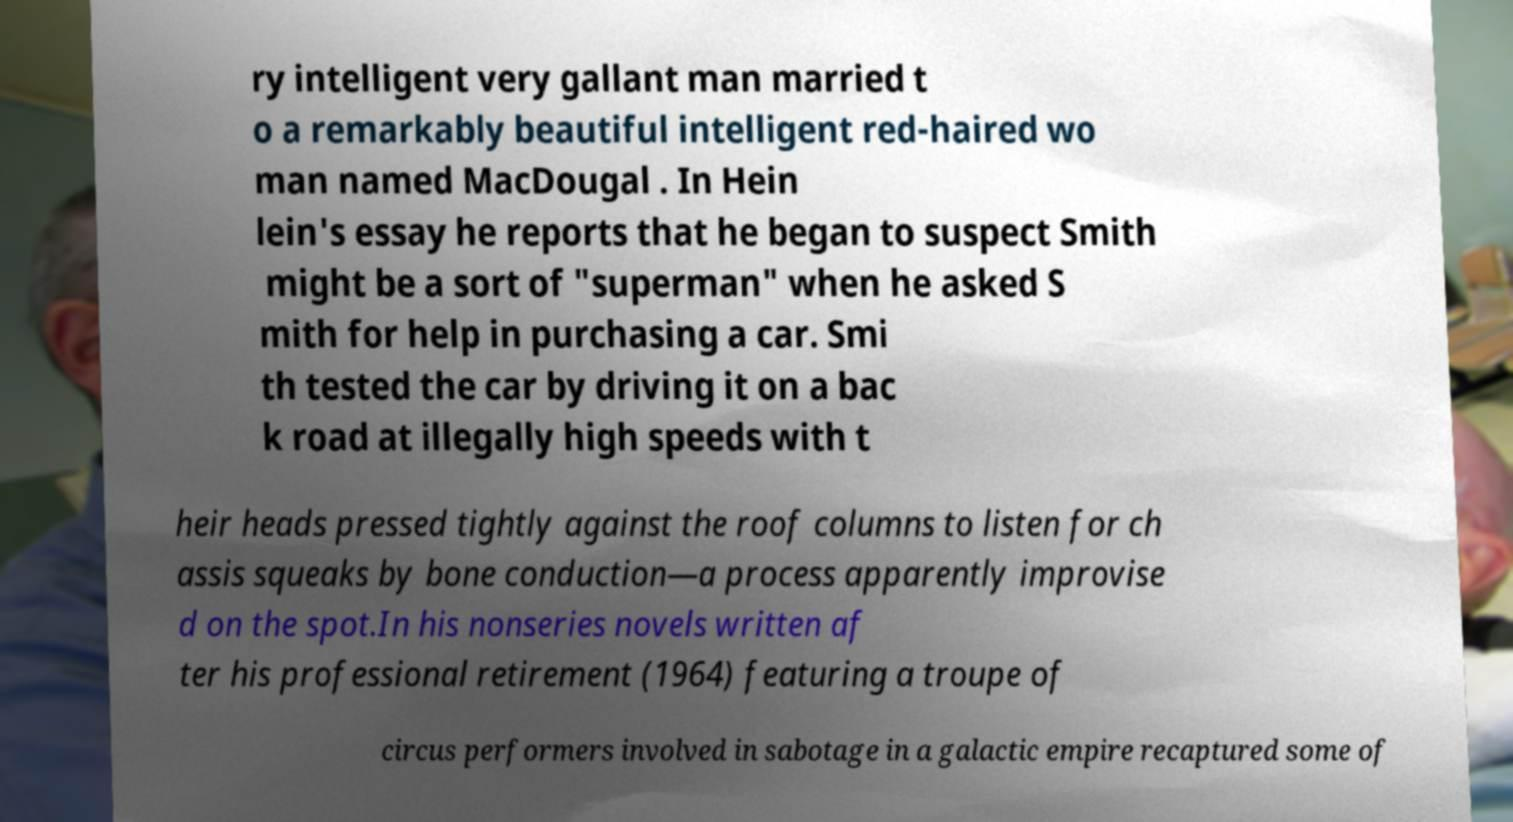There's text embedded in this image that I need extracted. Can you transcribe it verbatim? ry intelligent very gallant man married t o a remarkably beautiful intelligent red-haired wo man named MacDougal . In Hein lein's essay he reports that he began to suspect Smith might be a sort of "superman" when he asked S mith for help in purchasing a car. Smi th tested the car by driving it on a bac k road at illegally high speeds with t heir heads pressed tightly against the roof columns to listen for ch assis squeaks by bone conduction—a process apparently improvise d on the spot.In his nonseries novels written af ter his professional retirement (1964) featuring a troupe of circus performers involved in sabotage in a galactic empire recaptured some of 